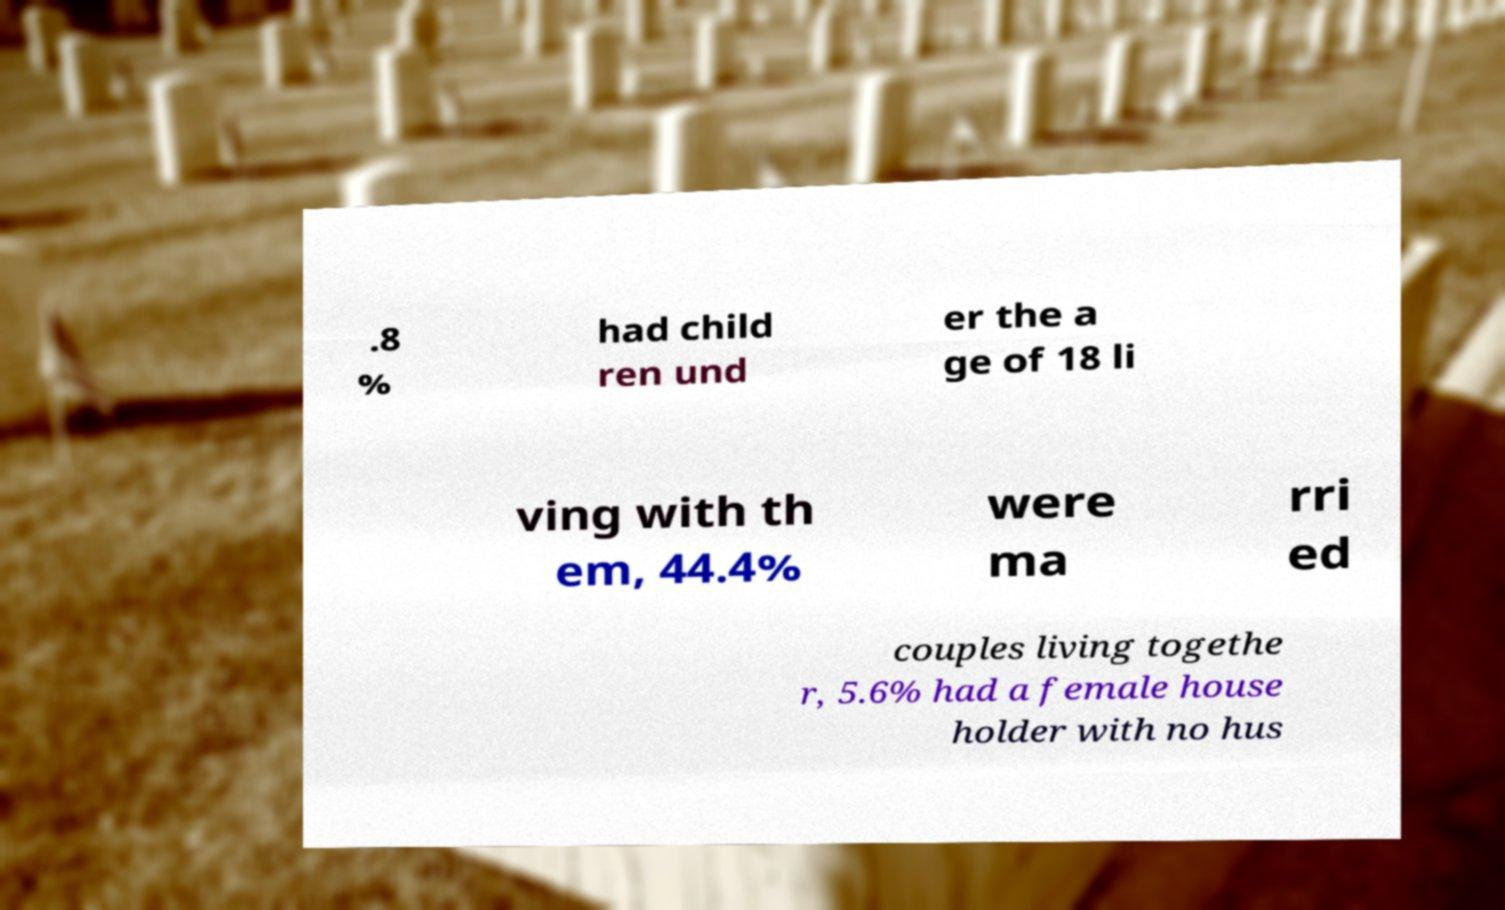Could you assist in decoding the text presented in this image and type it out clearly? .8 % had child ren und er the a ge of 18 li ving with th em, 44.4% were ma rri ed couples living togethe r, 5.6% had a female house holder with no hus 